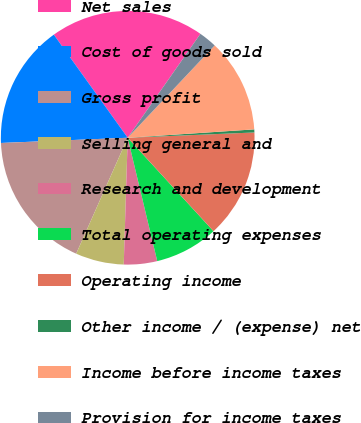<chart> <loc_0><loc_0><loc_500><loc_500><pie_chart><fcel>Net sales<fcel>Cost of goods sold<fcel>Gross profit<fcel>Selling general and<fcel>Research and development<fcel>Total operating expenses<fcel>Operating income<fcel>Other income / (expense) net<fcel>Income before income taxes<fcel>Provision for income taxes<nl><fcel>19.61%<fcel>15.76%<fcel>17.69%<fcel>6.16%<fcel>4.24%<fcel>8.08%<fcel>13.84%<fcel>0.39%<fcel>11.92%<fcel>2.31%<nl></chart> 